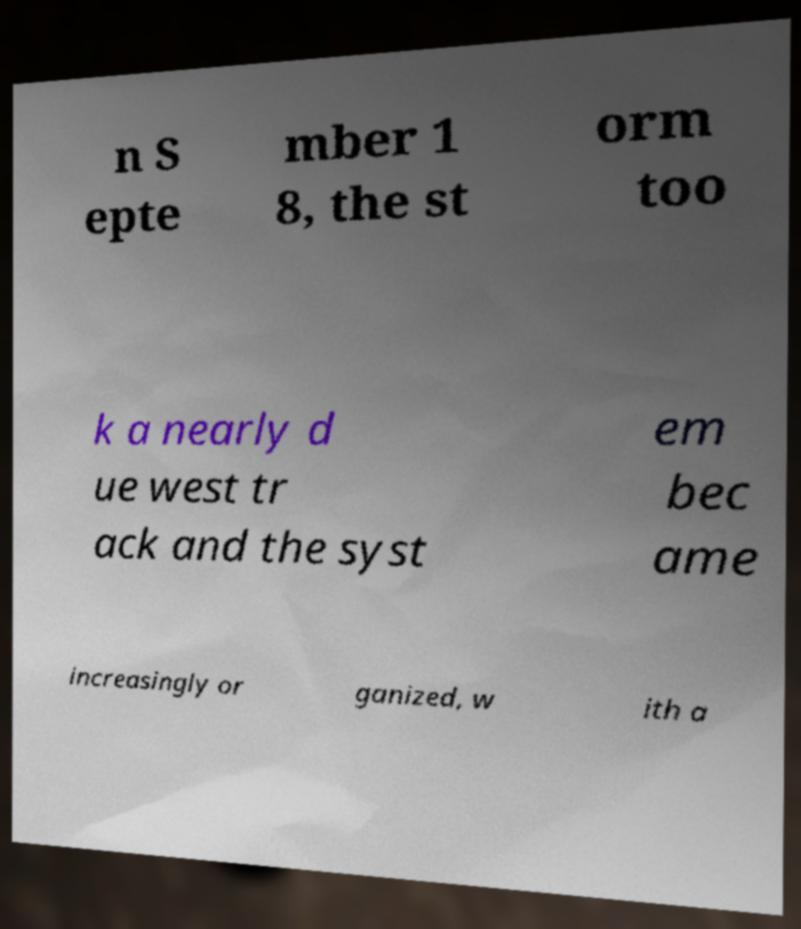Could you extract and type out the text from this image? n S epte mber 1 8, the st orm too k a nearly d ue west tr ack and the syst em bec ame increasingly or ganized, w ith a 